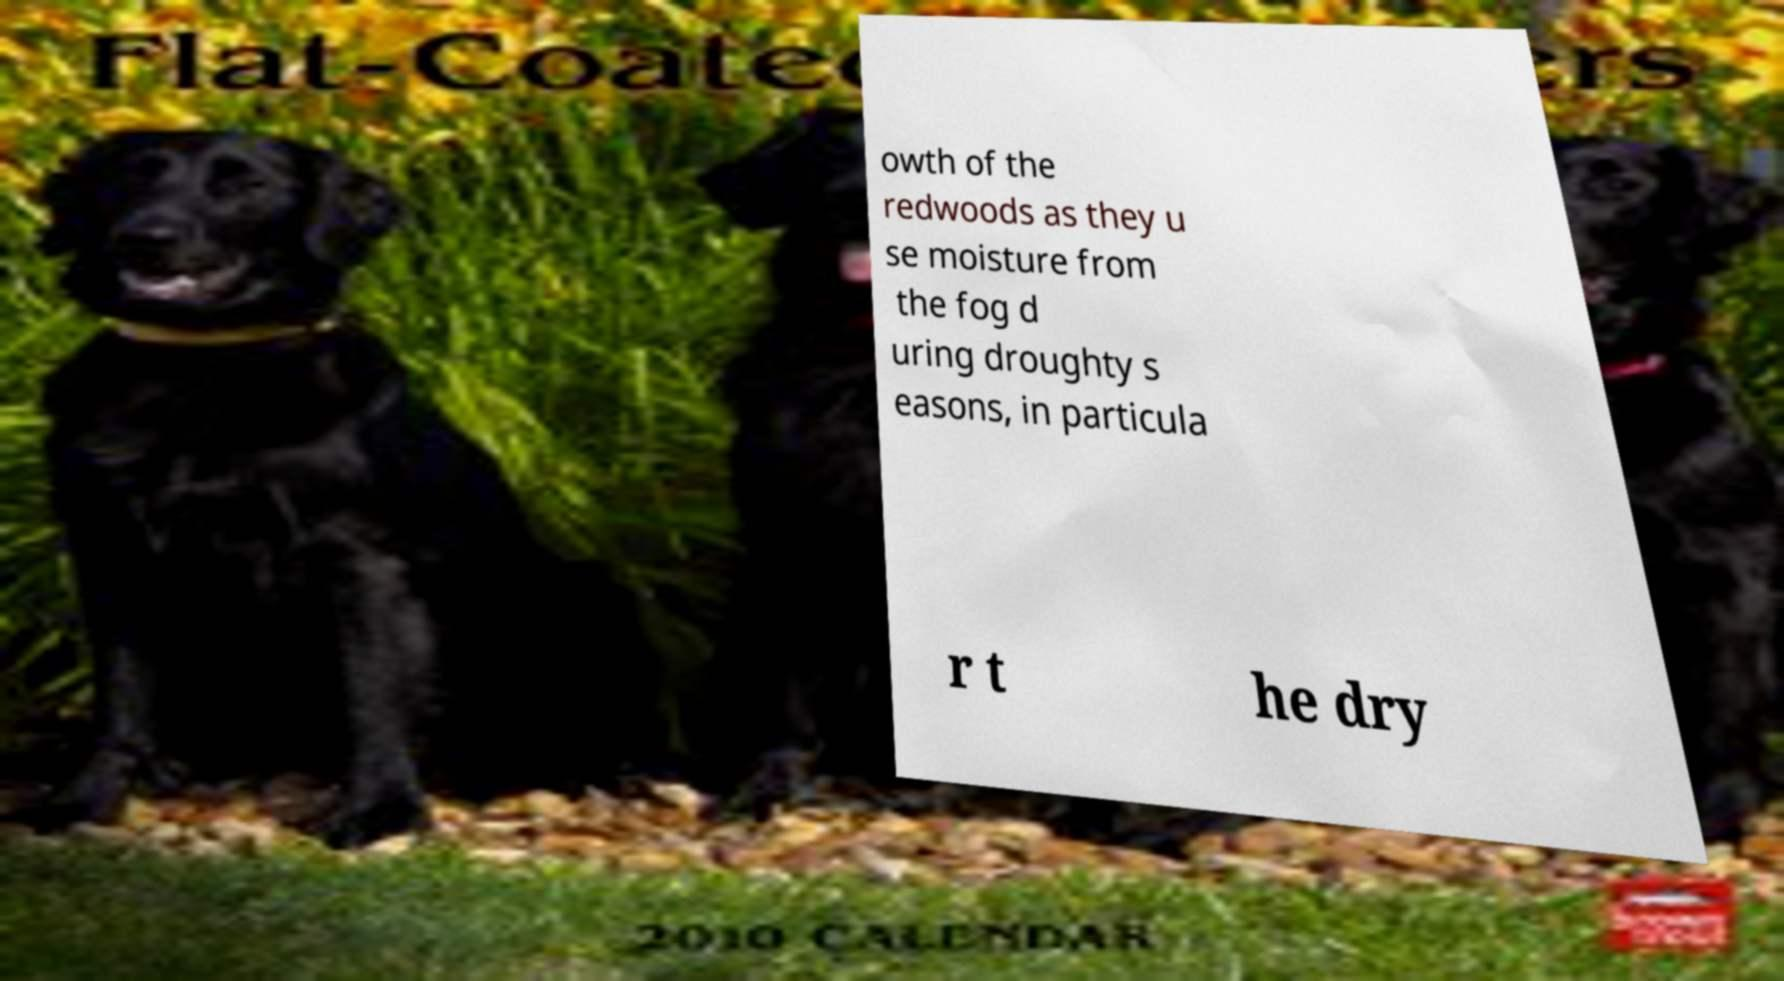Can you read and provide the text displayed in the image?This photo seems to have some interesting text. Can you extract and type it out for me? owth of the redwoods as they u se moisture from the fog d uring droughty s easons, in particula r t he dry 